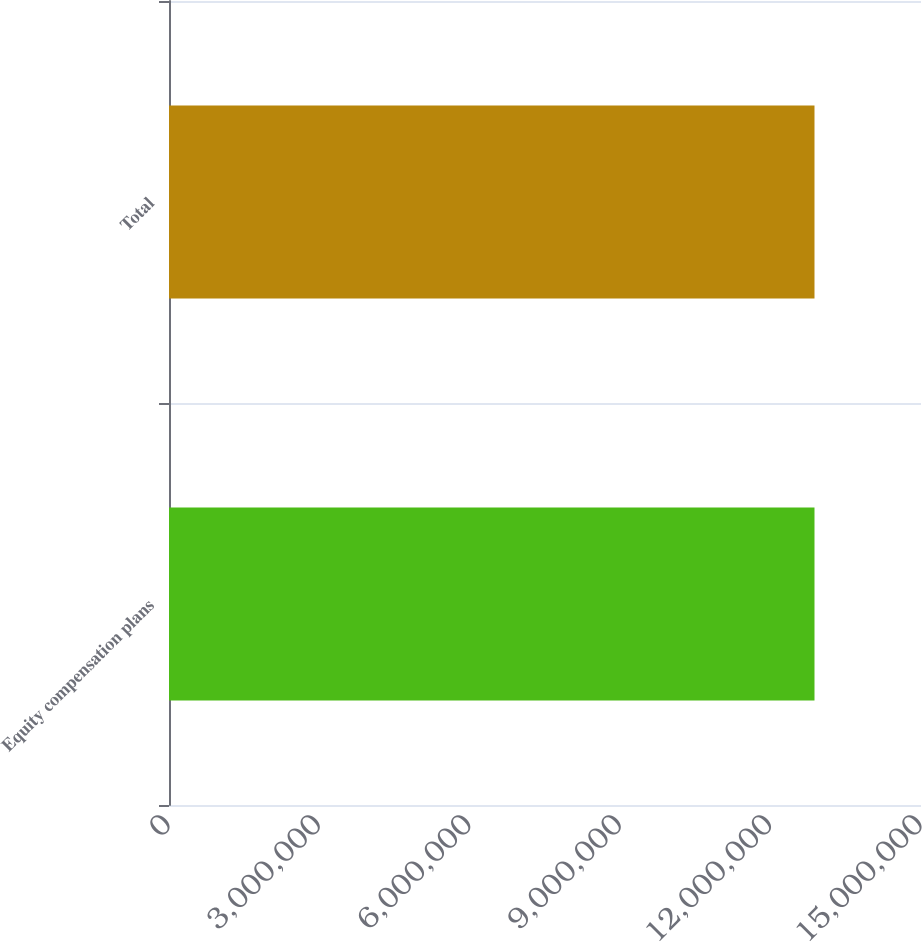<chart> <loc_0><loc_0><loc_500><loc_500><bar_chart><fcel>Equity compensation plans<fcel>Total<nl><fcel>1.28756e+07<fcel>1.28756e+07<nl></chart> 